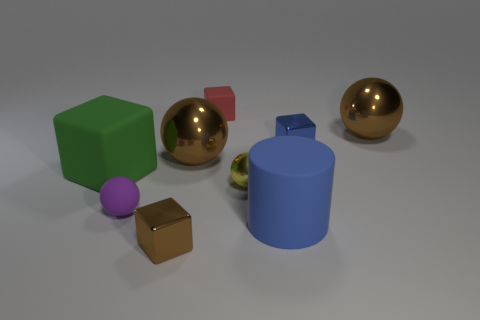Subtract all green matte blocks. How many blocks are left? 3 Subtract all cylinders. How many objects are left? 8 Subtract 1 cylinders. How many cylinders are left? 0 Subtract all tiny blue metal cubes. Subtract all large cyan shiny things. How many objects are left? 8 Add 5 large green matte blocks. How many large green matte blocks are left? 6 Add 4 tiny purple matte blocks. How many tiny purple matte blocks exist? 4 Subtract all green cubes. How many cubes are left? 3 Subtract 1 blue cylinders. How many objects are left? 8 Subtract all gray cylinders. Subtract all purple balls. How many cylinders are left? 1 Subtract all gray balls. How many brown blocks are left? 1 